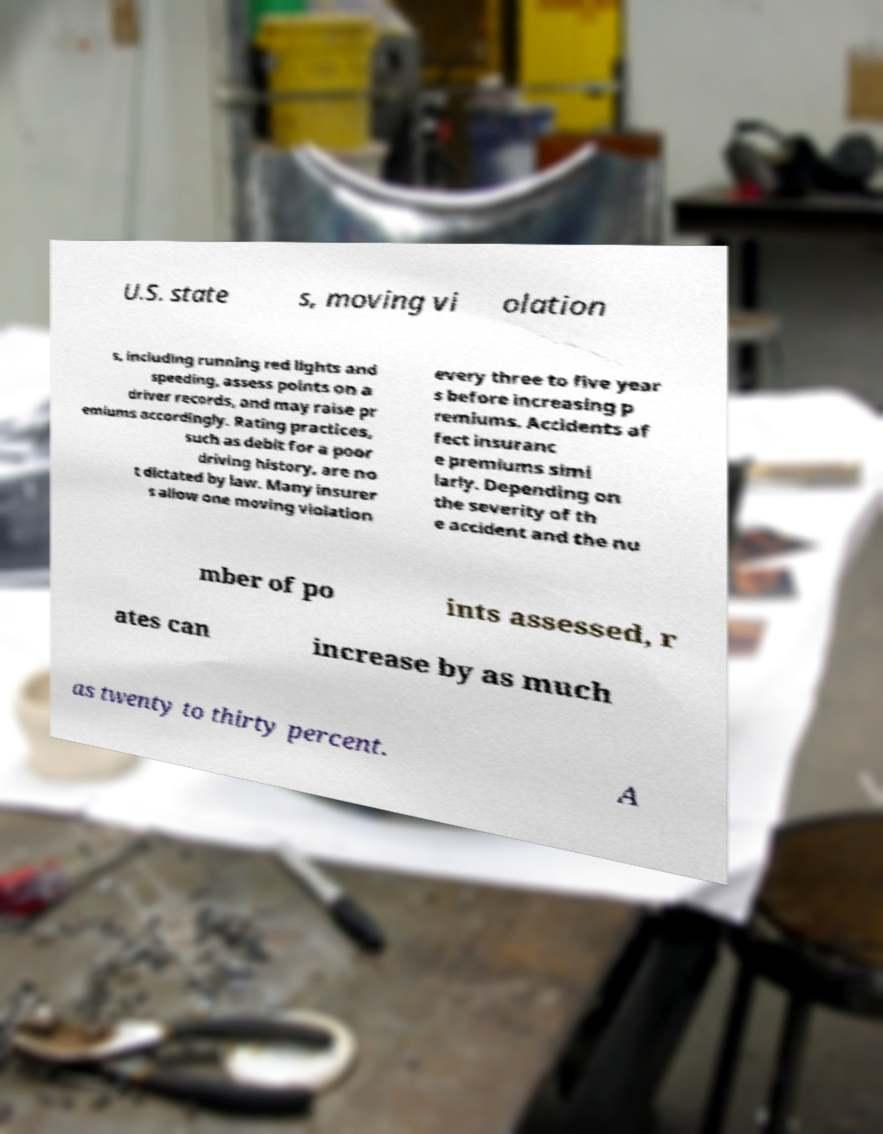Could you extract and type out the text from this image? U.S. state s, moving vi olation s, including running red lights and speeding, assess points on a driver records, and may raise pr emiums accordingly. Rating practices, such as debit for a poor driving history, are no t dictated by law. Many insurer s allow one moving violation every three to five year s before increasing p remiums. Accidents af fect insuranc e premiums simi larly. Depending on the severity of th e accident and the nu mber of po ints assessed, r ates can increase by as much as twenty to thirty percent. A 